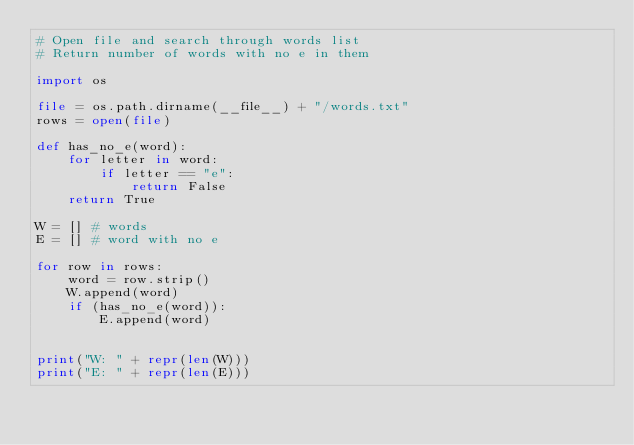Convert code to text. <code><loc_0><loc_0><loc_500><loc_500><_Python_># Open file and search through words list
# Return number of words with no e in them

import os

file = os.path.dirname(__file__) + "/words.txt"
rows = open(file)

def has_no_e(word):
    for letter in word:
        if letter == "e":
            return False
    return True

W = [] # words
E = [] # word with no e

for row in rows:
    word = row.strip()
    W.append(word)
    if (has_no_e(word)):
        E.append(word)  
    

print("W: " + repr(len(W)))
print("E: " + repr(len(E)))</code> 